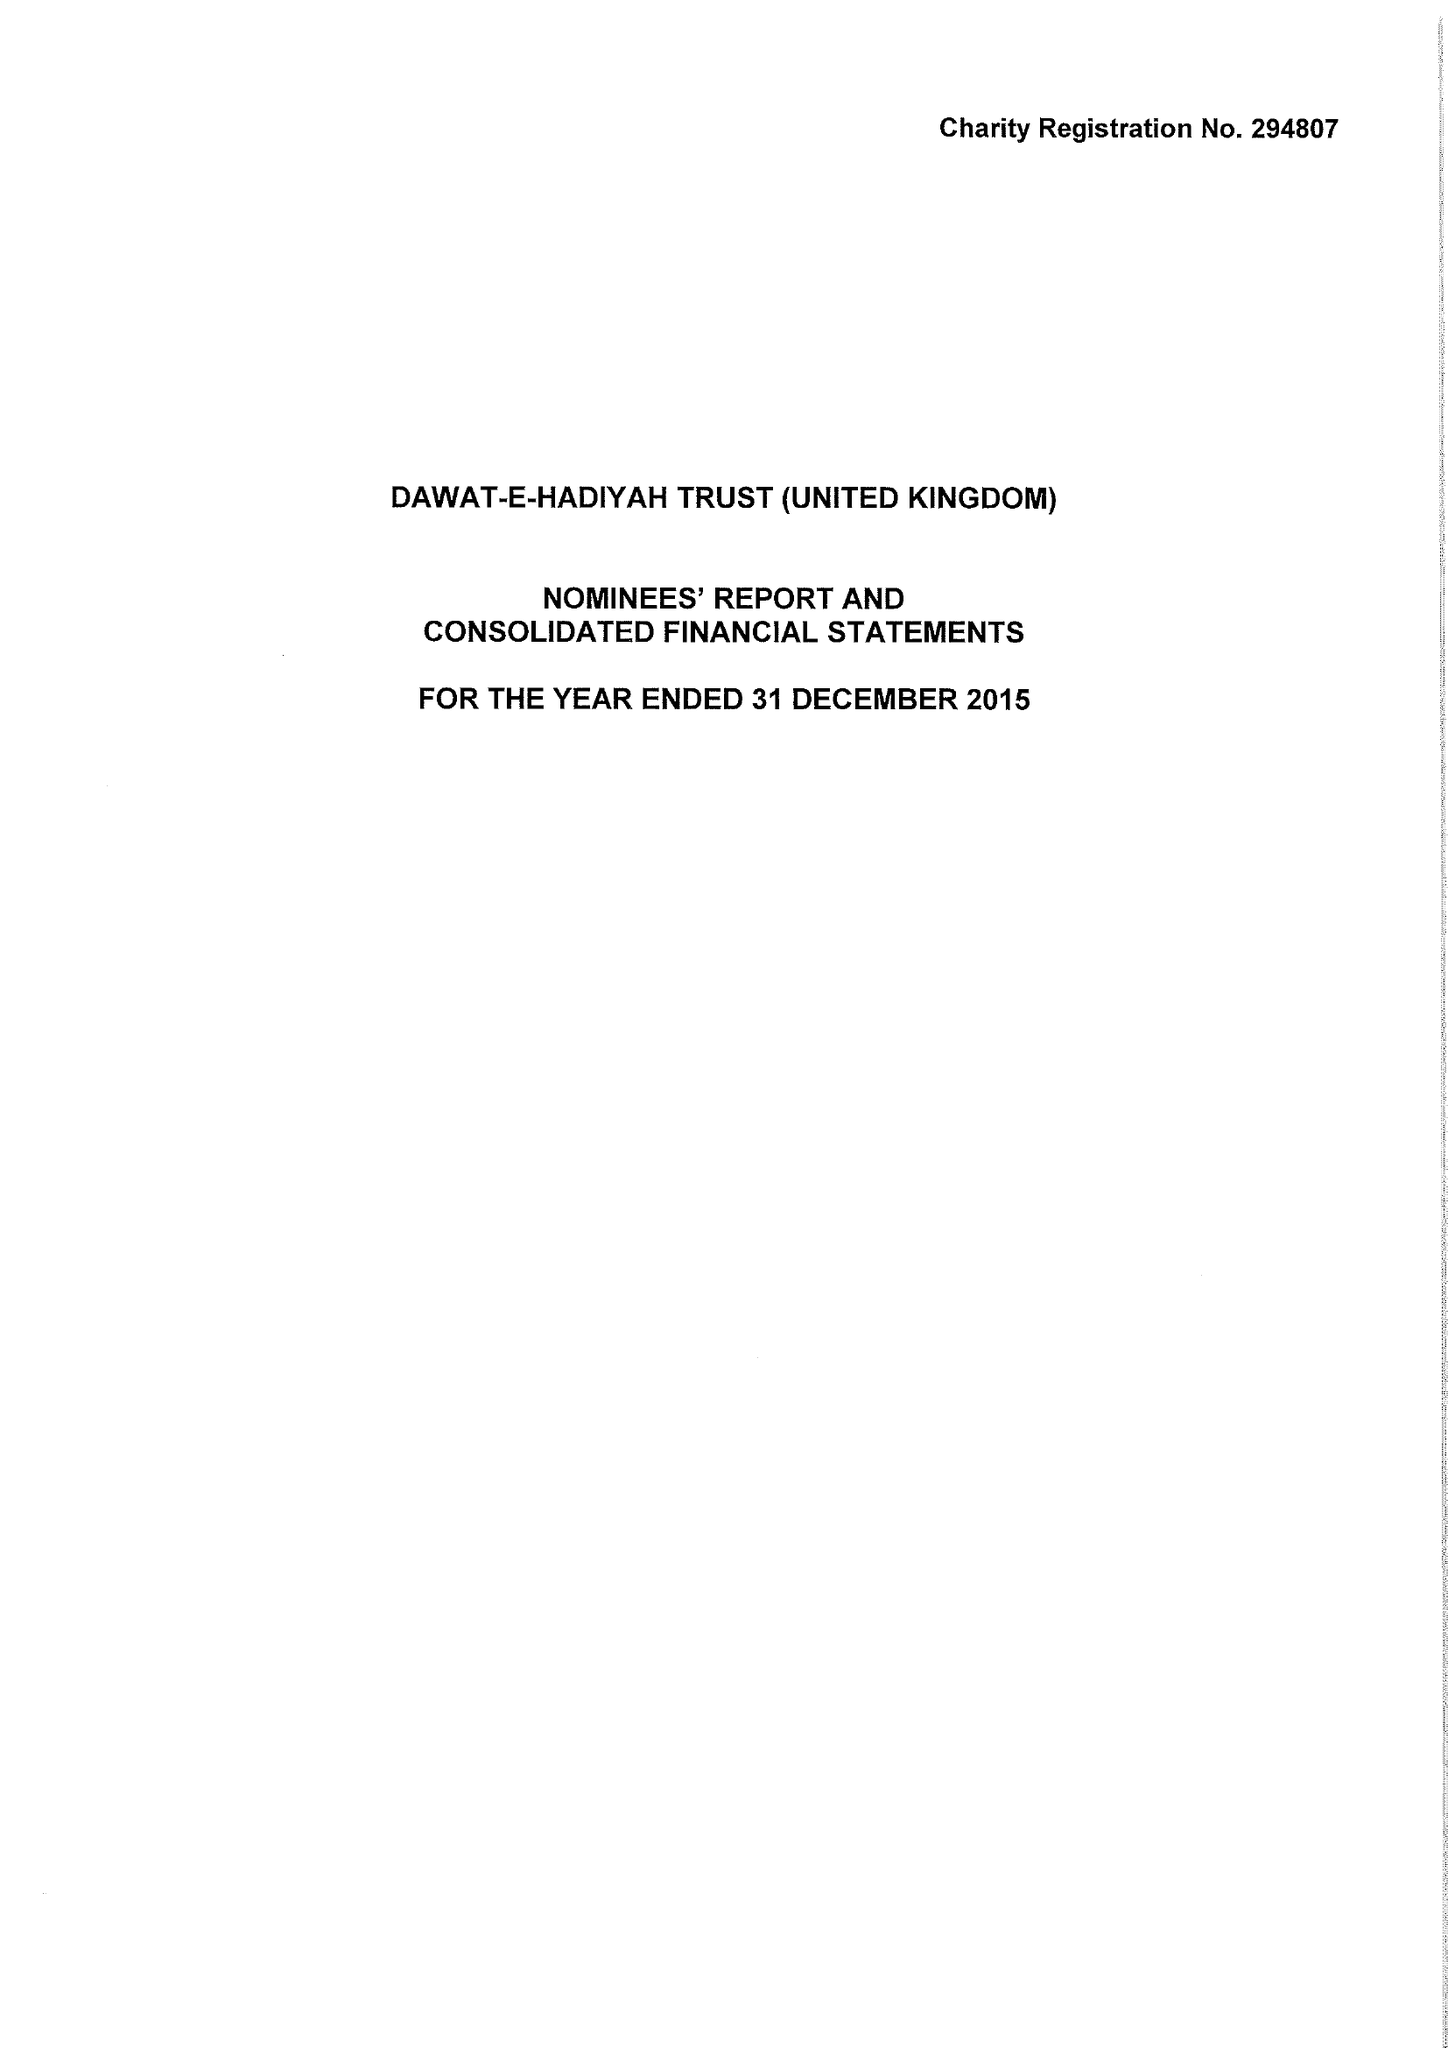What is the value for the spending_annually_in_british_pounds?
Answer the question using a single word or phrase. 8805333.00 